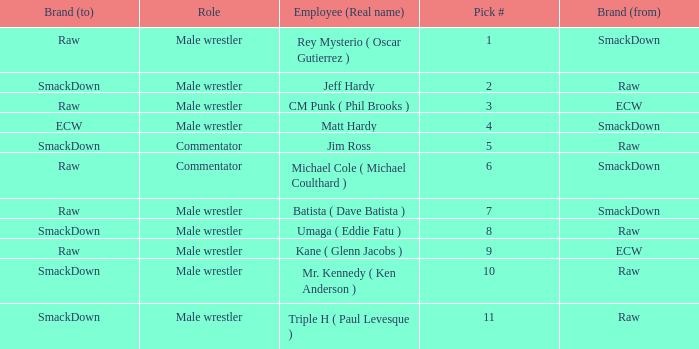What is the real name of the male wrestler from Raw with a pick # smaller than 6? Jeff Hardy. 